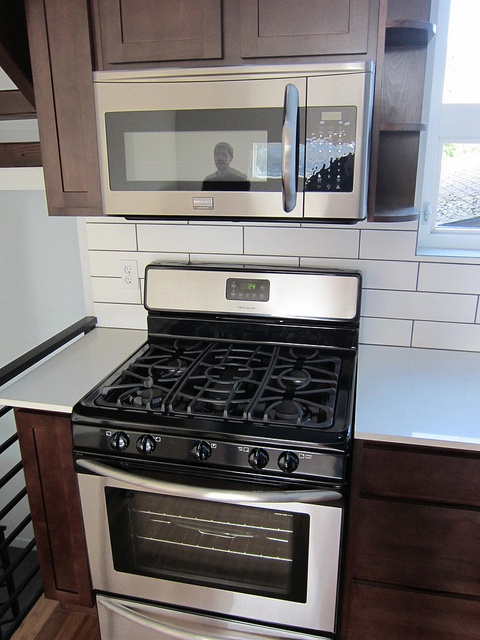Describe the objects in this image and their specific colors. I can see oven in black, gray, lightgray, and darkgray tones, microwave in black, darkgray, gray, lightgray, and tan tones, and people in black, gray, and darkgray tones in this image. 